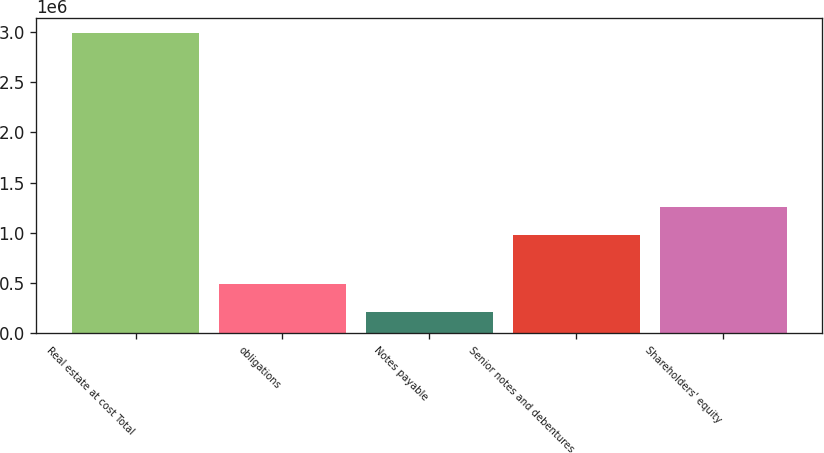<chart> <loc_0><loc_0><loc_500><loc_500><bar_chart><fcel>Real estate at cost Total<fcel>obligations<fcel>Notes payable<fcel>Senior notes and debentures<fcel>Shareholders' equity<nl><fcel>2.9893e+06<fcel>488668<fcel>210820<fcel>977556<fcel>1.2554e+06<nl></chart> 